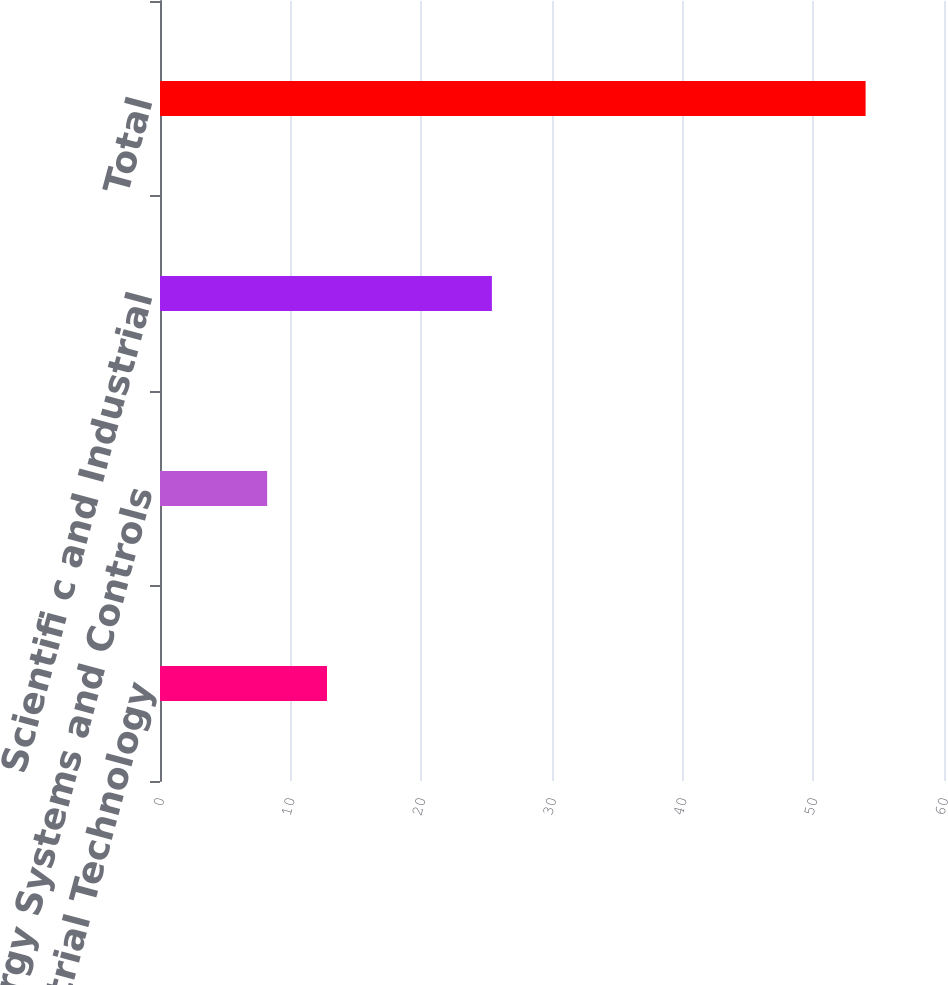Convert chart. <chart><loc_0><loc_0><loc_500><loc_500><bar_chart><fcel>Industrial Technology<fcel>Energy Systems and Controls<fcel>Scientifi c and Industrial<fcel>Total<nl><fcel>12.78<fcel>8.2<fcel>25.4<fcel>54<nl></chart> 